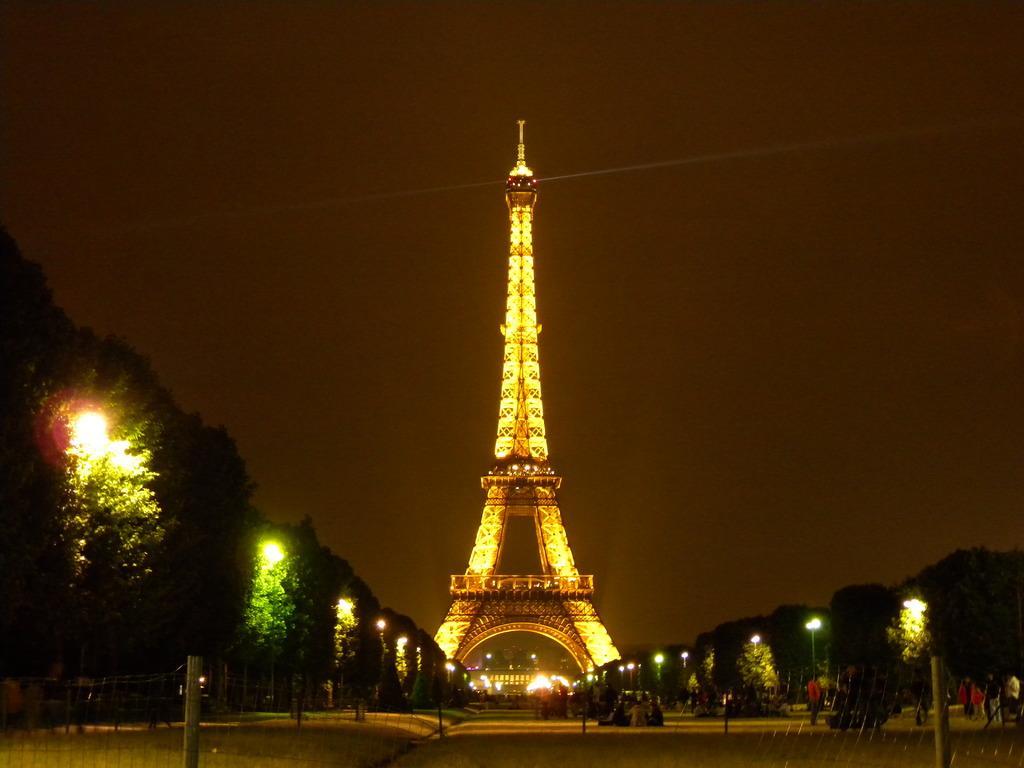Can you describe this image briefly? In the picture there is a tower, there are trees, there are poles with the lights, there are many people walking on the roads. 